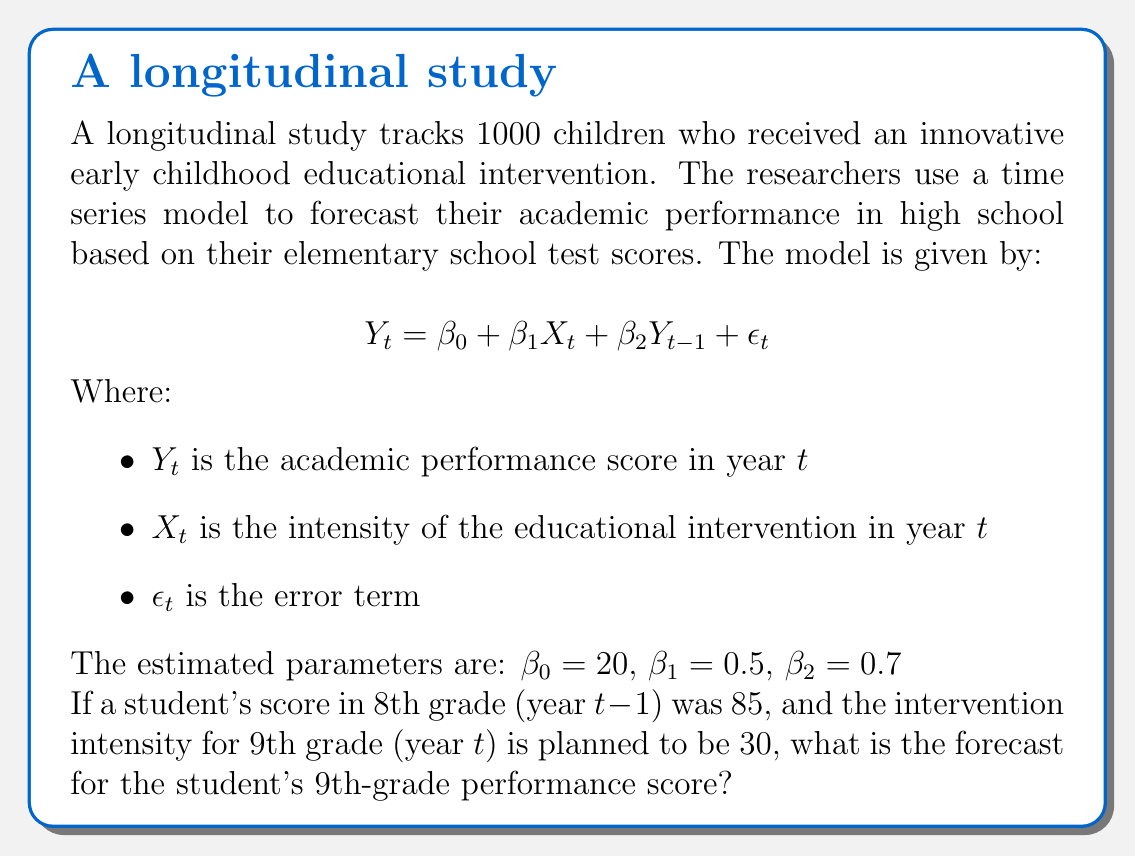Can you answer this question? To solve this problem, we need to use the given time series model and substitute the known values:

1. The model is: $Y_t = \beta_0 + \beta_1 X_t + \beta_2 Y_{t-1} + \epsilon_t$

2. We are given:
   $\beta_0 = 20$
   $\beta_1 = 0.5$
   $\beta_2 = 0.7$
   $X_t = 30$ (intervention intensity for 9th grade)
   $Y_{t-1} = 85$ (8th-grade score)

3. We need to find $Y_t$ (the forecast for 9th-grade performance)

4. Substituting these values into the equation:
   $Y_t = 20 + 0.5(30) + 0.7(85) + \epsilon_t$

5. Simplify:
   $Y_t = 20 + 15 + 59.5 + \epsilon_t$
   $Y_t = 94.5 + \epsilon_t$

6. In forecasting, we typically set the error term $\epsilon_t$ to its expected value of 0:
   $Y_t = 94.5 + 0 = 94.5$

Therefore, the forecast for the student's 9th-grade performance score is 94.5.
Answer: 94.5 